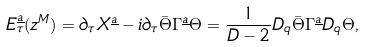<formula> <loc_0><loc_0><loc_500><loc_500>E _ { \tau } ^ { \underline { a } } ( z ^ { M } ) = \partial _ { \tau } X ^ { \underline { a } } - i \partial _ { \tau } \bar { \Theta } \Gamma ^ { \underline { a } } \Theta = \frac { 1 } { D - 2 } D _ { q } \bar { \Theta } \Gamma ^ { \underline { a } } D _ { q } \Theta ,</formula> 